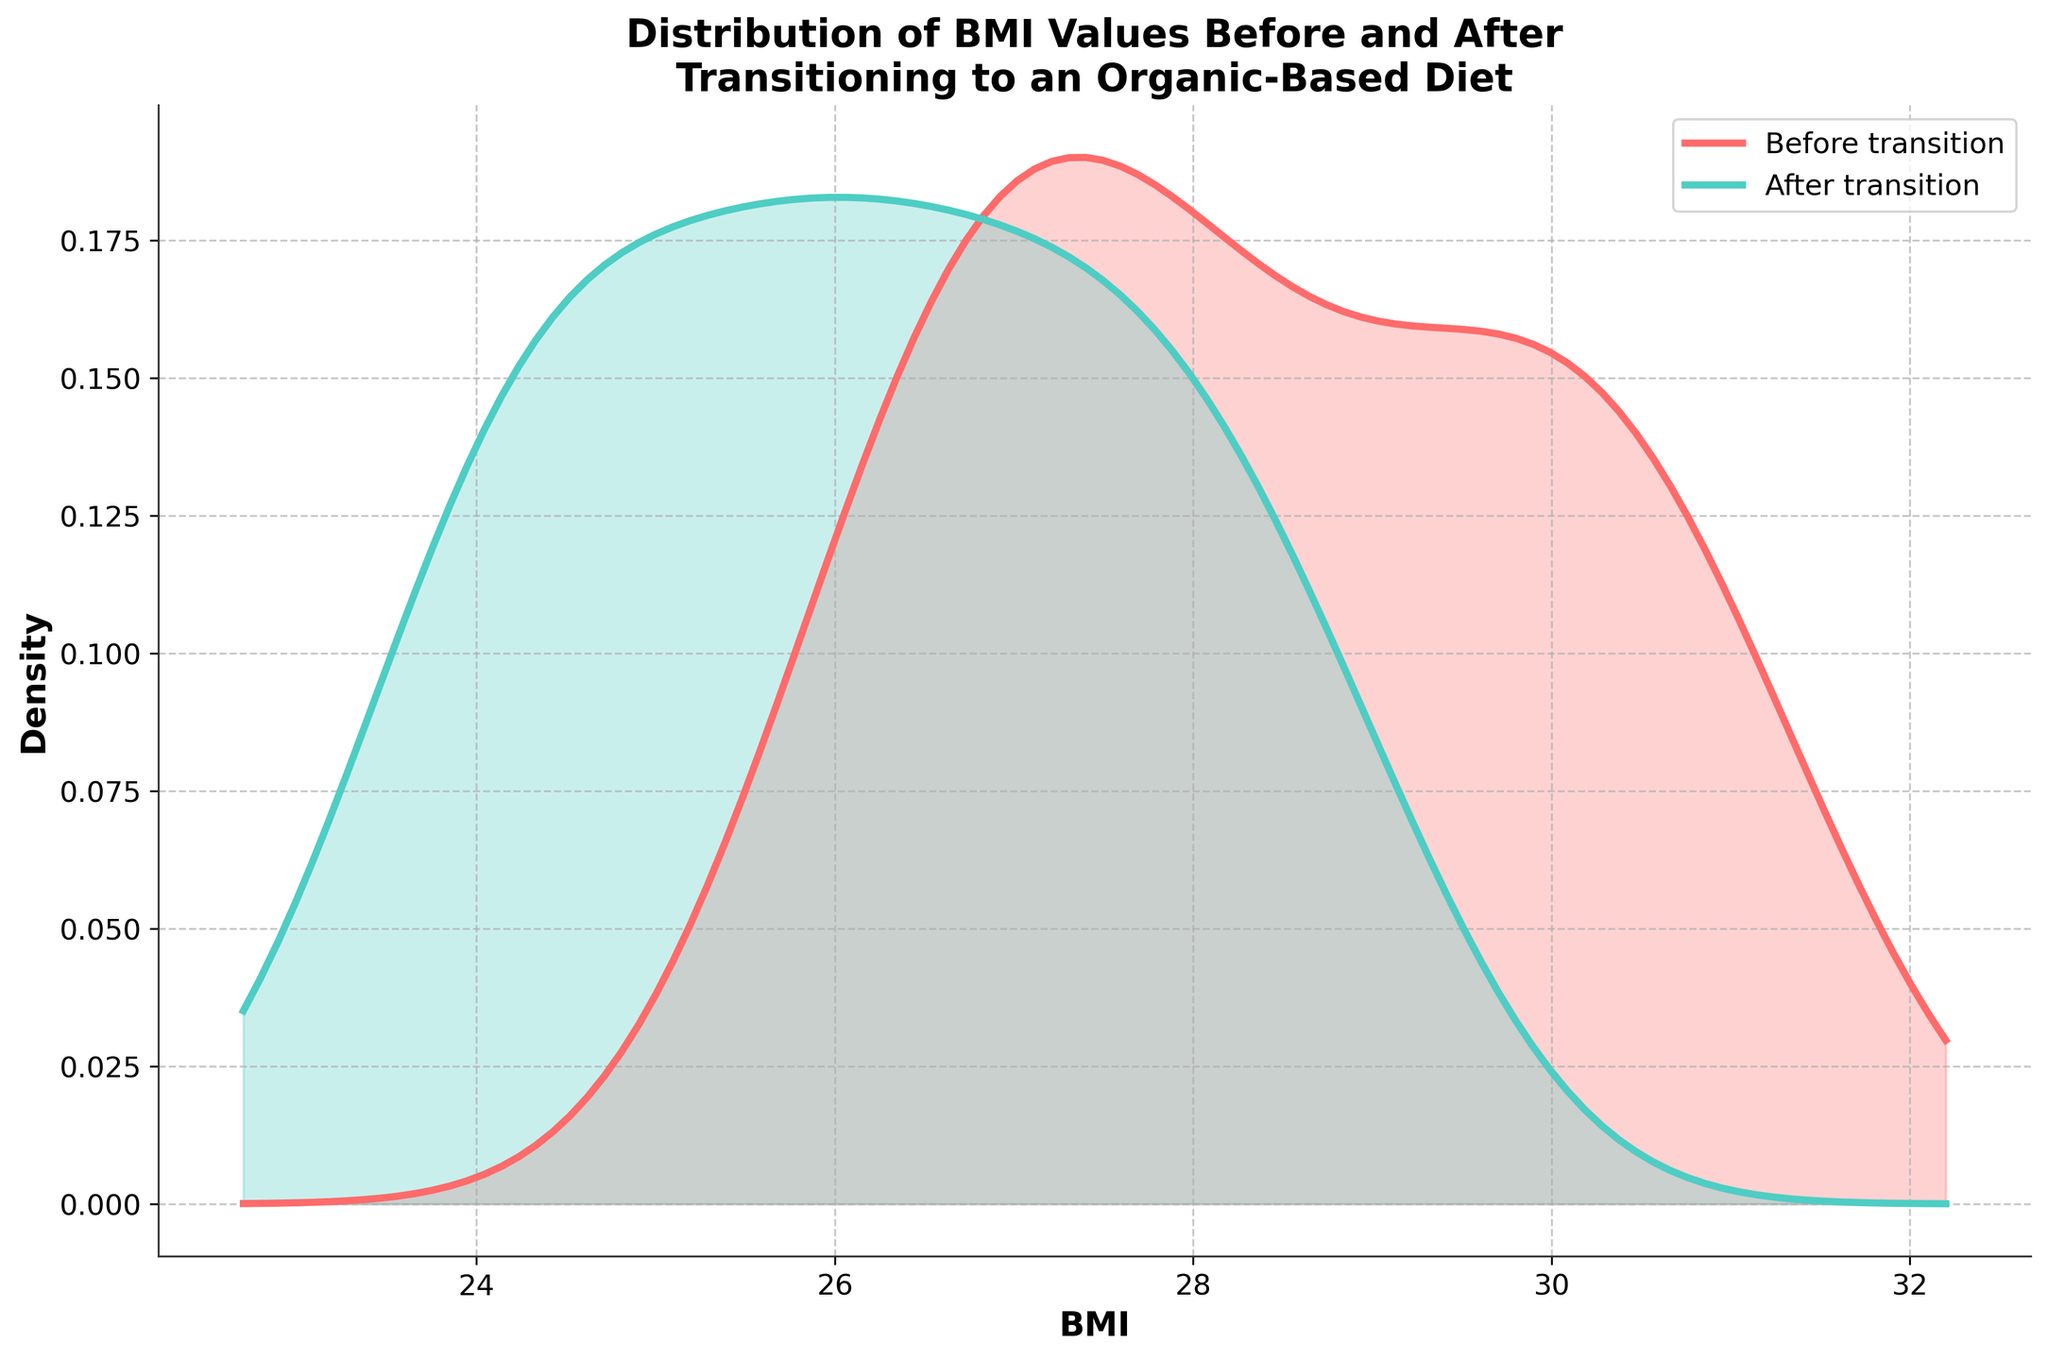How does the peak density of the BMI values change after transitioning to an organic-based diet? Observe the height of the peaks for both the before and after transition distributions to see if there is any increase or decrease.
Answer: It decreases What range does the x-axis cover in this plot? Identify the minimum and maximum values on the x-axis by looking at the axis labels.
Answer: Approximately 22 to 33 Which BMI distribution has a higher density at BMI = 28? Compare the densities shown on the y-axis for the before and after curves at the x-axis value of BMI = 28.
Answer: Before transition How do the mean BMI values before and after transitioning compare? Visually estimate the center points (means) of the "Before transition" and "After transition" distributions along the x-axis and compare them.
Answer: The mean BMI is higher before transitioning Is there an overlap between the BMI distributions before and after transitioning? Check where the filled areas of the two distributions intersect on the plot.
Answer: Yes Which distribution is more spread out, before or after transitioning? Observe the width of the curves (from lower to higher BMI values) for both distributions.
Answer: Before transition Are the distributions for BMI values before and after transitioning to an organic diet left-skewed or right-skewed? Examine the shape and tails of each curve to determine the skewness direction.
Answer: Symmetrical What is the trend in the BMI value of individuals who switched to an organic-based diet? Notice the general movement of the density from the "Before transition" to the "After transition" curve.
Answer: BMI values generally decrease 